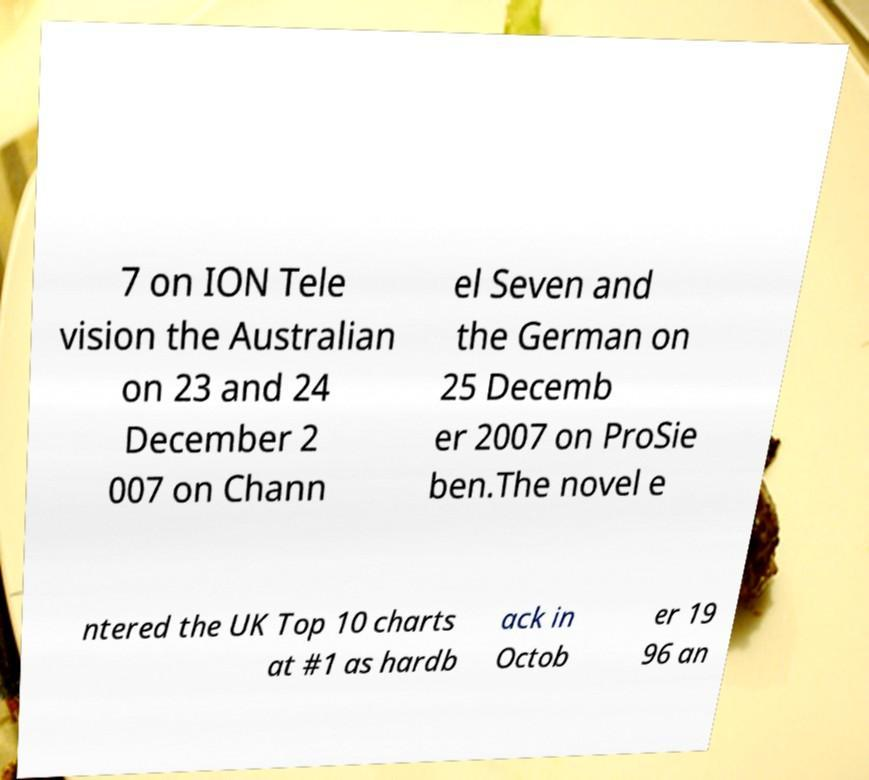Please identify and transcribe the text found in this image. 7 on ION Tele vision the Australian on 23 and 24 December 2 007 on Chann el Seven and the German on 25 Decemb er 2007 on ProSie ben.The novel e ntered the UK Top 10 charts at #1 as hardb ack in Octob er 19 96 an 